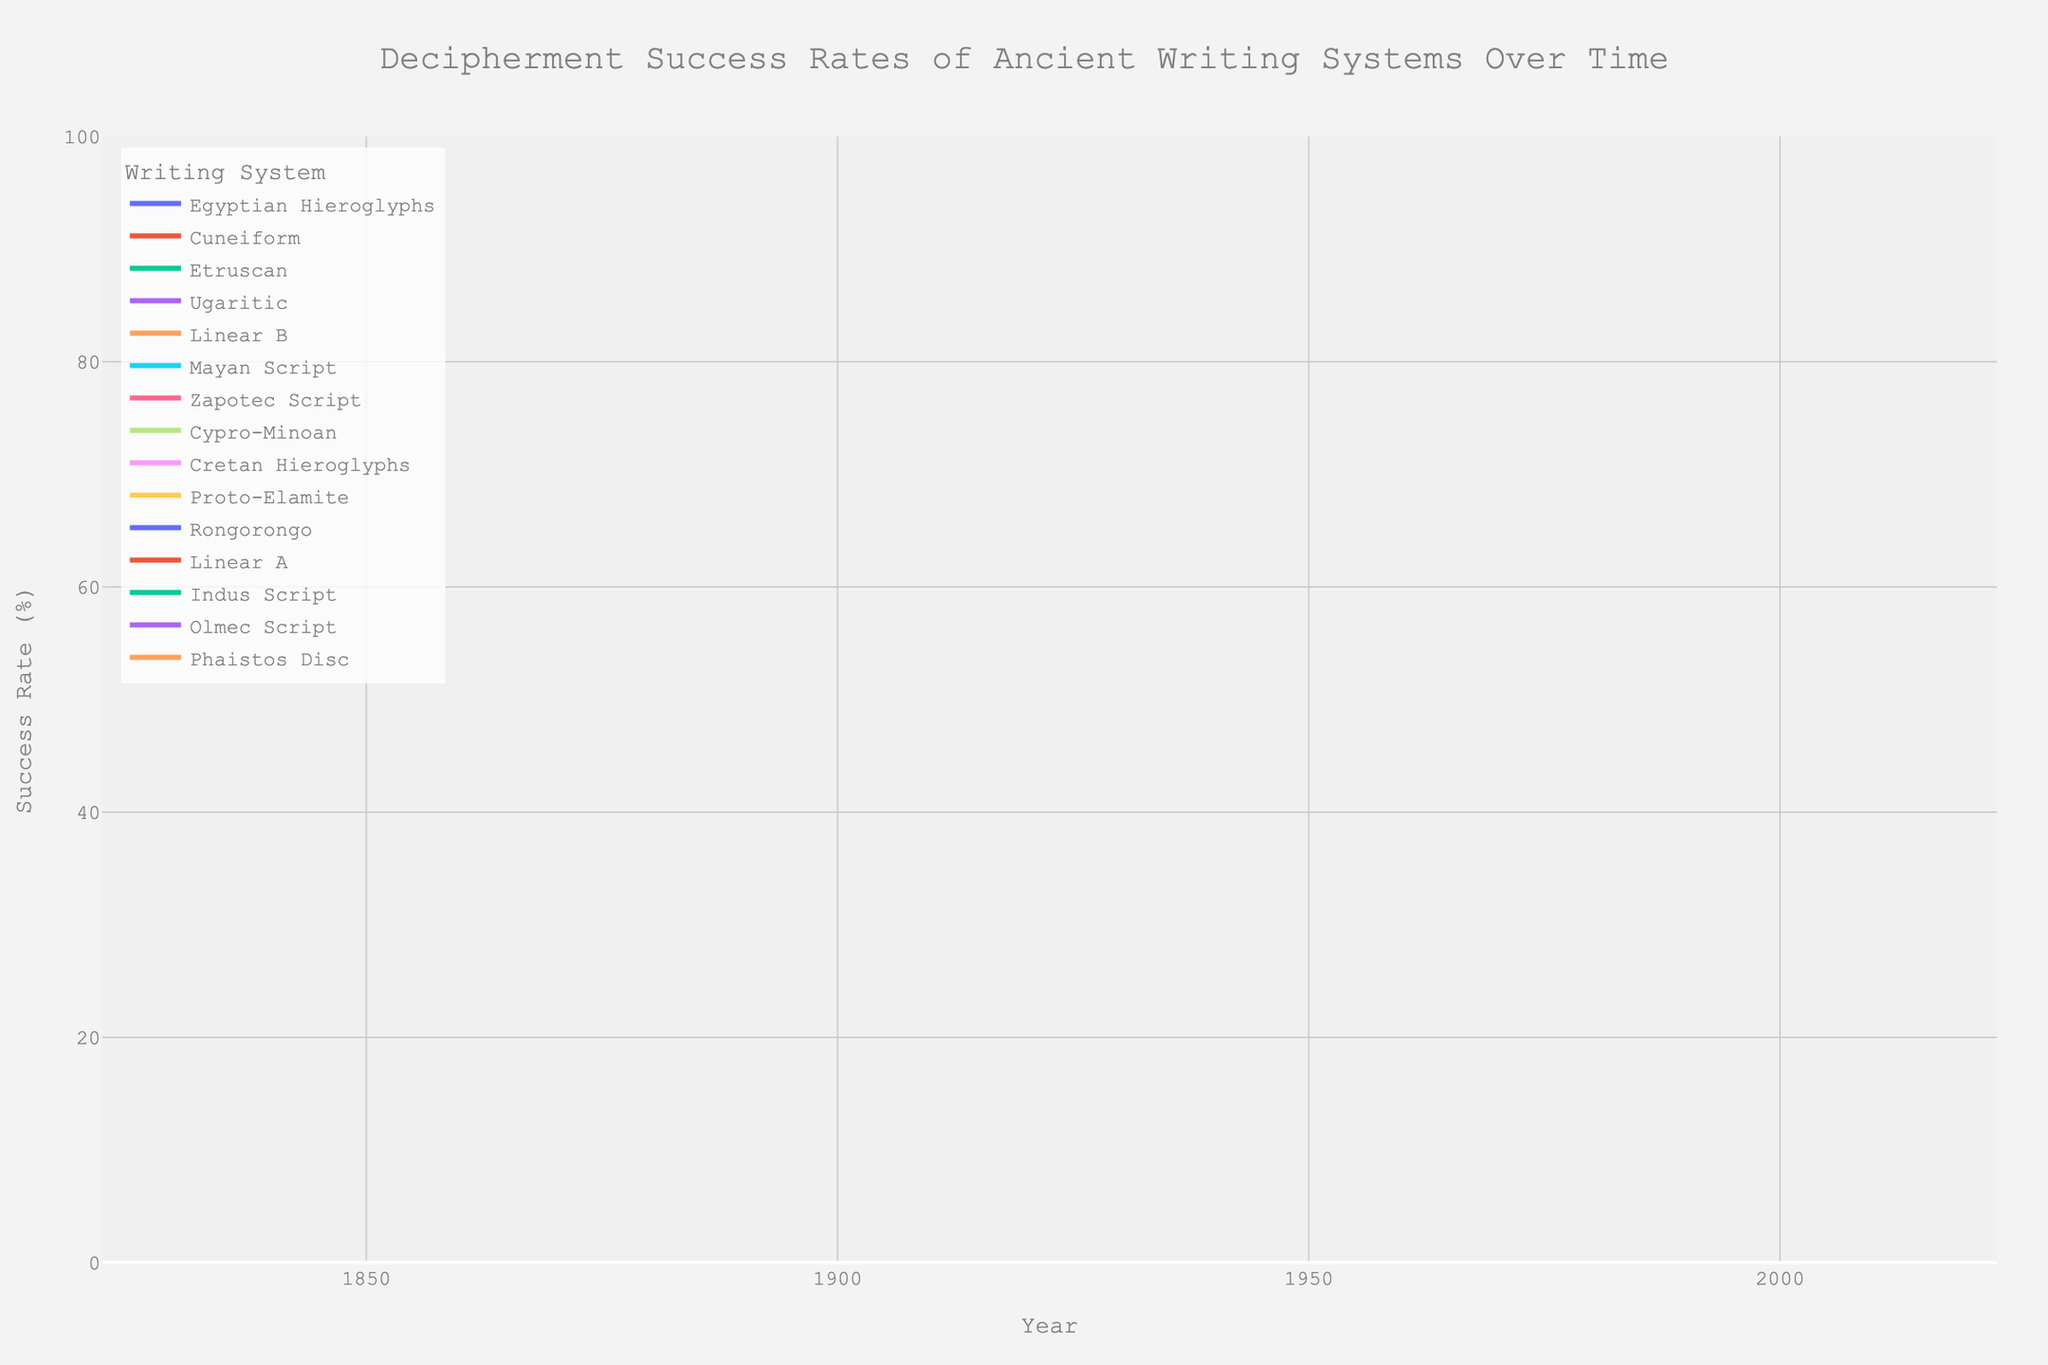What year shows the decipherment success rate for Mayan Script? The data point for "Mayan Script" has a corresponding year 1960 on the x-axis.
Answer: 1960 What is the difference in decipherment success rate between Ugaritic and Indus Script? Ugaritic has a success rate of 100%, and Indus Script has a 5% success rate. The difference is 100% - 5%.
Answer: 95% Which ancient writing system has the lowest decipherment success rate and what is it? Scanning the line chart, "Indus Script" stands out with the lowest success rate on the y-axis at 5%.
Answer: Indus Script at 5% Compare the decipherment success rates of Linear B and Linear A. Which one is higher and by how much? Linear B has a success rate of 95%, while Linear A has 20%. The difference is 95% - 20%.
Answer: Linear B by 75% What is the average decipherment success rate of all ancient writing systems depicted in the figure? Summing all the success rates and dividing by the number of writing systems for a mean: (95 + 98 + 85 + 92 + 75 + 10 + 30 + 20 + 5 + 60 + 15 + 40 + 25 + 50 + 100) / 15.
Answer: 55% How many ancient writing systems have a decipherment success rate of 50% or above? Counting the systems with success rates 50% or above: Linear B, Egyptian Hieroglyphs, Mayan Script, Cuneiform, Etruscan, Zapotec Script, Cypro-Minoan, Ugaritic. Total = 8.
Answer: 8 Which writing systems were deciphered after the year 2000? Scanning the x-axis for years after 2000 reveals: Rongorongo, Proto-Elamite, Linear A, Indus Script, Olmec Script, Cretan Hieroglyphs, Phaistos Disc, Cypro-Minoan.
Answer: 8 systems What is the median decipherment success rate of the depicted writing systems? Ordering the success rates and selecting the middle value if odd number, or average of two middle values if even: [5, 10, 15, 20, 25, 30, 40, 50, 60, 75, 85, 92, 95, 98, 100], median is the 8th value in an ordered 15-item list.
Answer: 50% Which ancient writing system appears to have been deciphered the earliest and in what year? The earliest year on the x-axis is 1822, which corresponds to Egyptian Hieroglyphs.
Answer: Egyptian Hieroglyphs, 1822 What is the total success rate for all ancient writing systems deciphered in 2023? Summing success rates for systems deciphered in 2023: Rongorongo (10), Linear A (20), Indus Script (5), Olmec Script (15), Phaistos Disc (25). Total = 10 + 20 + 5 + 15 + 25.
Answer: 75% 